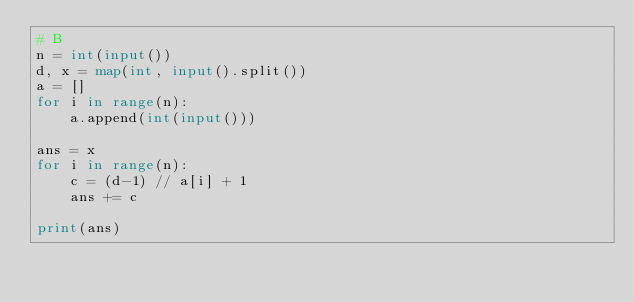<code> <loc_0><loc_0><loc_500><loc_500><_Python_># B
n = int(input())
d, x = map(int, input().split())
a = []
for i in range(n):
    a.append(int(input()))
    
ans = x
for i in range(n):
    c = (d-1) // a[i] + 1
    ans += c
    
print(ans)</code> 